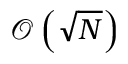Convert formula to latex. <formula><loc_0><loc_0><loc_500><loc_500>\mathcal { O } \left ( \sqrt { N } \right )</formula> 